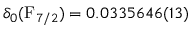Convert formula to latex. <formula><loc_0><loc_0><loc_500><loc_500>\delta _ { 0 } ( F _ { 7 / 2 } ) = 0 . 0 3 3 5 6 4 6 ( 1 3 )</formula> 